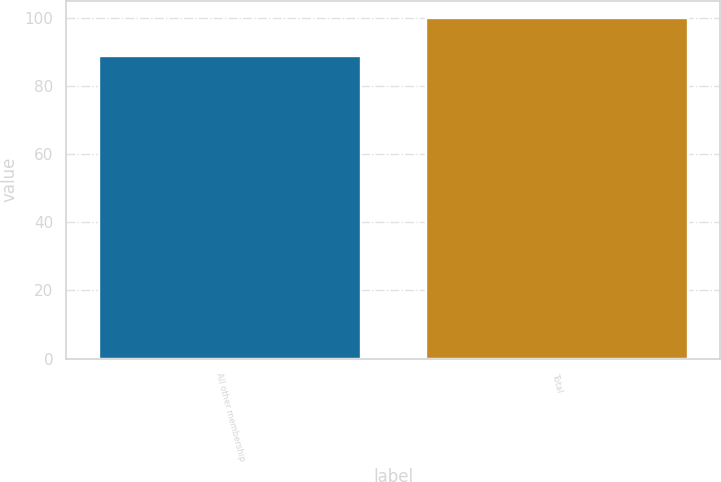Convert chart. <chart><loc_0><loc_0><loc_500><loc_500><bar_chart><fcel>All other membership<fcel>Total<nl><fcel>88.9<fcel>100<nl></chart> 